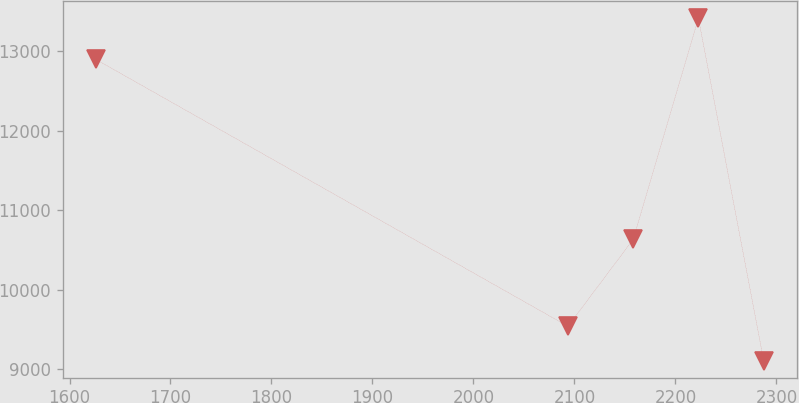Convert chart to OTSL. <chart><loc_0><loc_0><loc_500><loc_500><line_chart><ecel><fcel>Unnamed: 1<nl><fcel>1626.16<fcel>12893.9<nl><fcel>2093.56<fcel>9537.9<nl><fcel>2158.17<fcel>10631.2<nl><fcel>2222.78<fcel>13412.7<nl><fcel>2287.39<fcel>9107.36<nl></chart> 